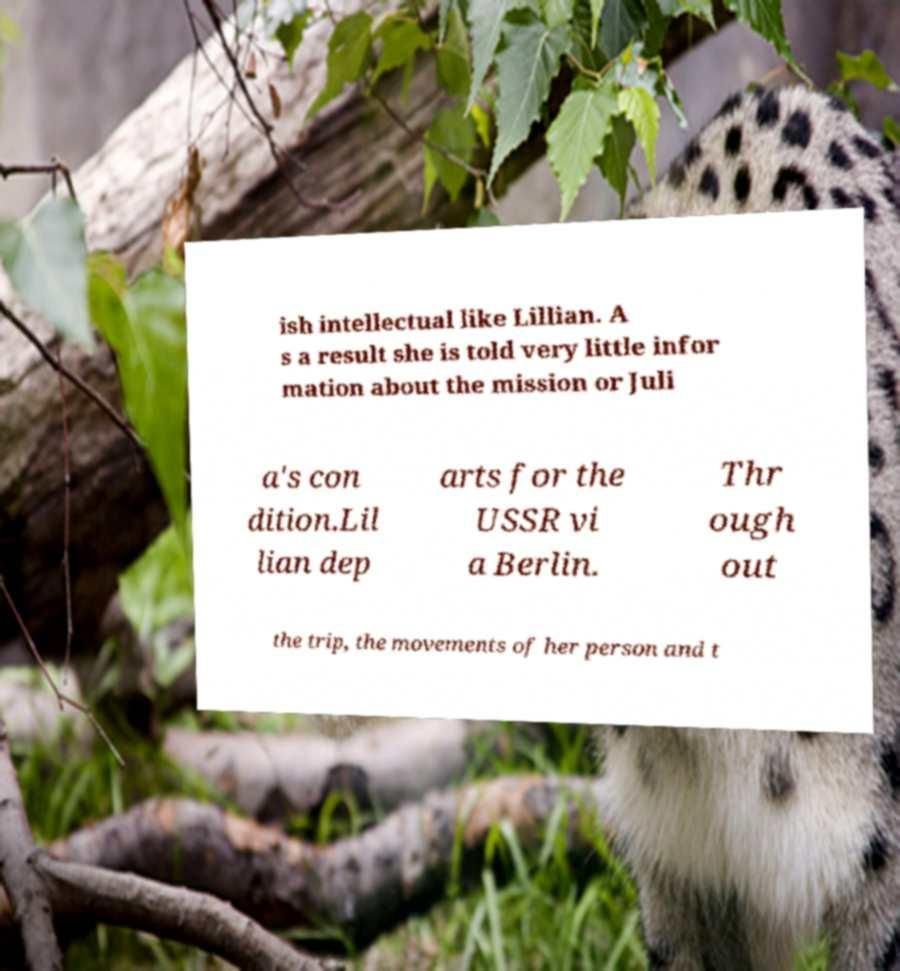What messages or text are displayed in this image? I need them in a readable, typed format. ish intellectual like Lillian. A s a result she is told very little infor mation about the mission or Juli a's con dition.Lil lian dep arts for the USSR vi a Berlin. Thr ough out the trip, the movements of her person and t 